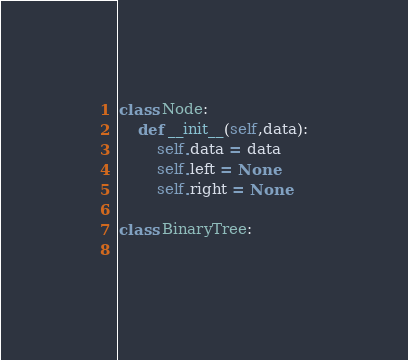<code> <loc_0><loc_0><loc_500><loc_500><_Python_>class Node:
    def __init__(self,data):
        self.data = data
        self.left = None
        self.right = None

class BinaryTree:
    
</code> 